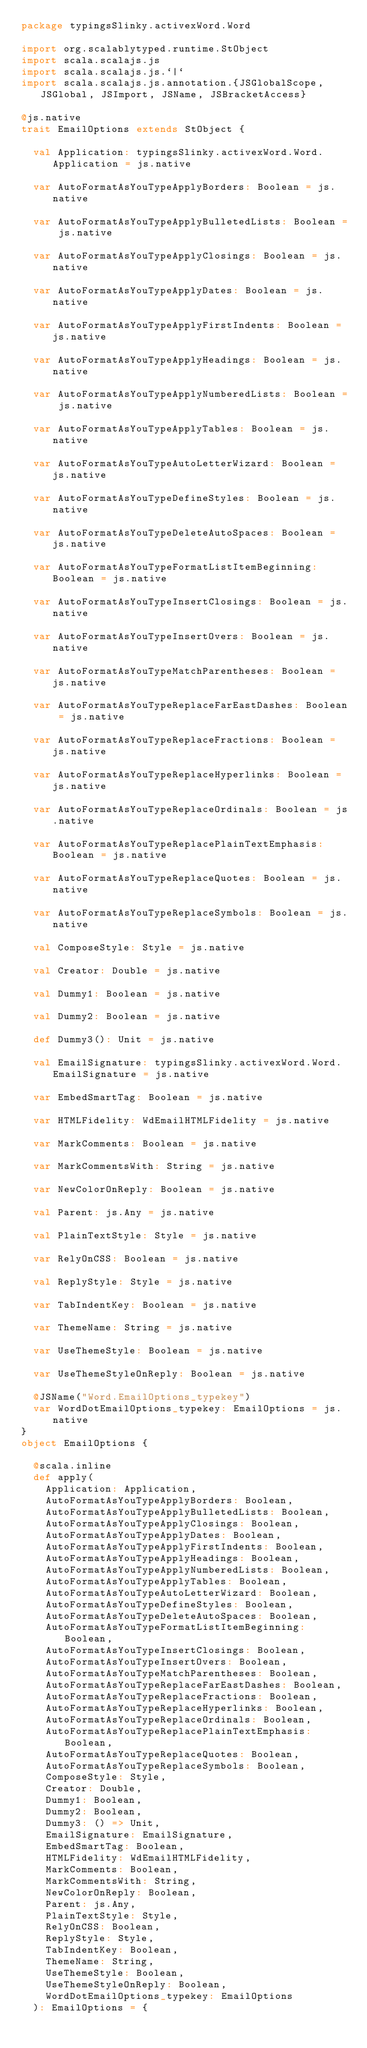Convert code to text. <code><loc_0><loc_0><loc_500><loc_500><_Scala_>package typingsSlinky.activexWord.Word

import org.scalablytyped.runtime.StObject
import scala.scalajs.js
import scala.scalajs.js.`|`
import scala.scalajs.js.annotation.{JSGlobalScope, JSGlobal, JSImport, JSName, JSBracketAccess}

@js.native
trait EmailOptions extends StObject {
  
  val Application: typingsSlinky.activexWord.Word.Application = js.native
  
  var AutoFormatAsYouTypeApplyBorders: Boolean = js.native
  
  var AutoFormatAsYouTypeApplyBulletedLists: Boolean = js.native
  
  var AutoFormatAsYouTypeApplyClosings: Boolean = js.native
  
  var AutoFormatAsYouTypeApplyDates: Boolean = js.native
  
  var AutoFormatAsYouTypeApplyFirstIndents: Boolean = js.native
  
  var AutoFormatAsYouTypeApplyHeadings: Boolean = js.native
  
  var AutoFormatAsYouTypeApplyNumberedLists: Boolean = js.native
  
  var AutoFormatAsYouTypeApplyTables: Boolean = js.native
  
  var AutoFormatAsYouTypeAutoLetterWizard: Boolean = js.native
  
  var AutoFormatAsYouTypeDefineStyles: Boolean = js.native
  
  var AutoFormatAsYouTypeDeleteAutoSpaces: Boolean = js.native
  
  var AutoFormatAsYouTypeFormatListItemBeginning: Boolean = js.native
  
  var AutoFormatAsYouTypeInsertClosings: Boolean = js.native
  
  var AutoFormatAsYouTypeInsertOvers: Boolean = js.native
  
  var AutoFormatAsYouTypeMatchParentheses: Boolean = js.native
  
  var AutoFormatAsYouTypeReplaceFarEastDashes: Boolean = js.native
  
  var AutoFormatAsYouTypeReplaceFractions: Boolean = js.native
  
  var AutoFormatAsYouTypeReplaceHyperlinks: Boolean = js.native
  
  var AutoFormatAsYouTypeReplaceOrdinals: Boolean = js.native
  
  var AutoFormatAsYouTypeReplacePlainTextEmphasis: Boolean = js.native
  
  var AutoFormatAsYouTypeReplaceQuotes: Boolean = js.native
  
  var AutoFormatAsYouTypeReplaceSymbols: Boolean = js.native
  
  val ComposeStyle: Style = js.native
  
  val Creator: Double = js.native
  
  val Dummy1: Boolean = js.native
  
  val Dummy2: Boolean = js.native
  
  def Dummy3(): Unit = js.native
  
  val EmailSignature: typingsSlinky.activexWord.Word.EmailSignature = js.native
  
  var EmbedSmartTag: Boolean = js.native
  
  var HTMLFidelity: WdEmailHTMLFidelity = js.native
  
  var MarkComments: Boolean = js.native
  
  var MarkCommentsWith: String = js.native
  
  var NewColorOnReply: Boolean = js.native
  
  val Parent: js.Any = js.native
  
  val PlainTextStyle: Style = js.native
  
  var RelyOnCSS: Boolean = js.native
  
  val ReplyStyle: Style = js.native
  
  var TabIndentKey: Boolean = js.native
  
  var ThemeName: String = js.native
  
  var UseThemeStyle: Boolean = js.native
  
  var UseThemeStyleOnReply: Boolean = js.native
  
  @JSName("Word.EmailOptions_typekey")
  var WordDotEmailOptions_typekey: EmailOptions = js.native
}
object EmailOptions {
  
  @scala.inline
  def apply(
    Application: Application,
    AutoFormatAsYouTypeApplyBorders: Boolean,
    AutoFormatAsYouTypeApplyBulletedLists: Boolean,
    AutoFormatAsYouTypeApplyClosings: Boolean,
    AutoFormatAsYouTypeApplyDates: Boolean,
    AutoFormatAsYouTypeApplyFirstIndents: Boolean,
    AutoFormatAsYouTypeApplyHeadings: Boolean,
    AutoFormatAsYouTypeApplyNumberedLists: Boolean,
    AutoFormatAsYouTypeApplyTables: Boolean,
    AutoFormatAsYouTypeAutoLetterWizard: Boolean,
    AutoFormatAsYouTypeDefineStyles: Boolean,
    AutoFormatAsYouTypeDeleteAutoSpaces: Boolean,
    AutoFormatAsYouTypeFormatListItemBeginning: Boolean,
    AutoFormatAsYouTypeInsertClosings: Boolean,
    AutoFormatAsYouTypeInsertOvers: Boolean,
    AutoFormatAsYouTypeMatchParentheses: Boolean,
    AutoFormatAsYouTypeReplaceFarEastDashes: Boolean,
    AutoFormatAsYouTypeReplaceFractions: Boolean,
    AutoFormatAsYouTypeReplaceHyperlinks: Boolean,
    AutoFormatAsYouTypeReplaceOrdinals: Boolean,
    AutoFormatAsYouTypeReplacePlainTextEmphasis: Boolean,
    AutoFormatAsYouTypeReplaceQuotes: Boolean,
    AutoFormatAsYouTypeReplaceSymbols: Boolean,
    ComposeStyle: Style,
    Creator: Double,
    Dummy1: Boolean,
    Dummy2: Boolean,
    Dummy3: () => Unit,
    EmailSignature: EmailSignature,
    EmbedSmartTag: Boolean,
    HTMLFidelity: WdEmailHTMLFidelity,
    MarkComments: Boolean,
    MarkCommentsWith: String,
    NewColorOnReply: Boolean,
    Parent: js.Any,
    PlainTextStyle: Style,
    RelyOnCSS: Boolean,
    ReplyStyle: Style,
    TabIndentKey: Boolean,
    ThemeName: String,
    UseThemeStyle: Boolean,
    UseThemeStyleOnReply: Boolean,
    WordDotEmailOptions_typekey: EmailOptions
  ): EmailOptions = {</code> 